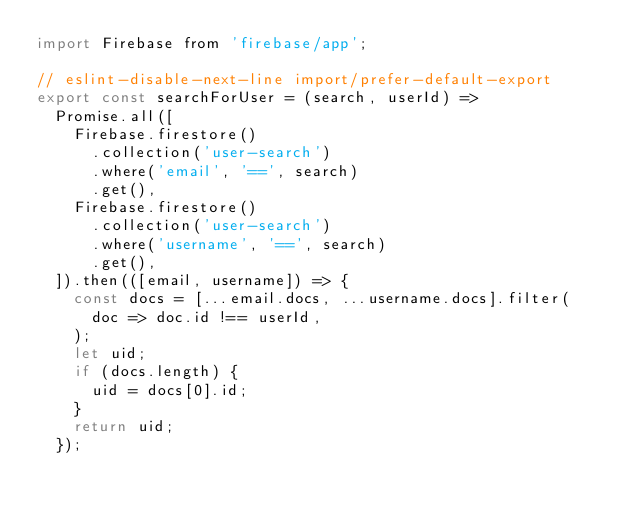<code> <loc_0><loc_0><loc_500><loc_500><_JavaScript_>import Firebase from 'firebase/app';

// eslint-disable-next-line import/prefer-default-export
export const searchForUser = (search, userId) =>
  Promise.all([
    Firebase.firestore()
      .collection('user-search')
      .where('email', '==', search)
      .get(),
    Firebase.firestore()
      .collection('user-search')
      .where('username', '==', search)
      .get(),
  ]).then(([email, username]) => {
    const docs = [...email.docs, ...username.docs].filter(
      doc => doc.id !== userId,
    );
    let uid;
    if (docs.length) {
      uid = docs[0].id;
    }
    return uid;
  });
</code> 